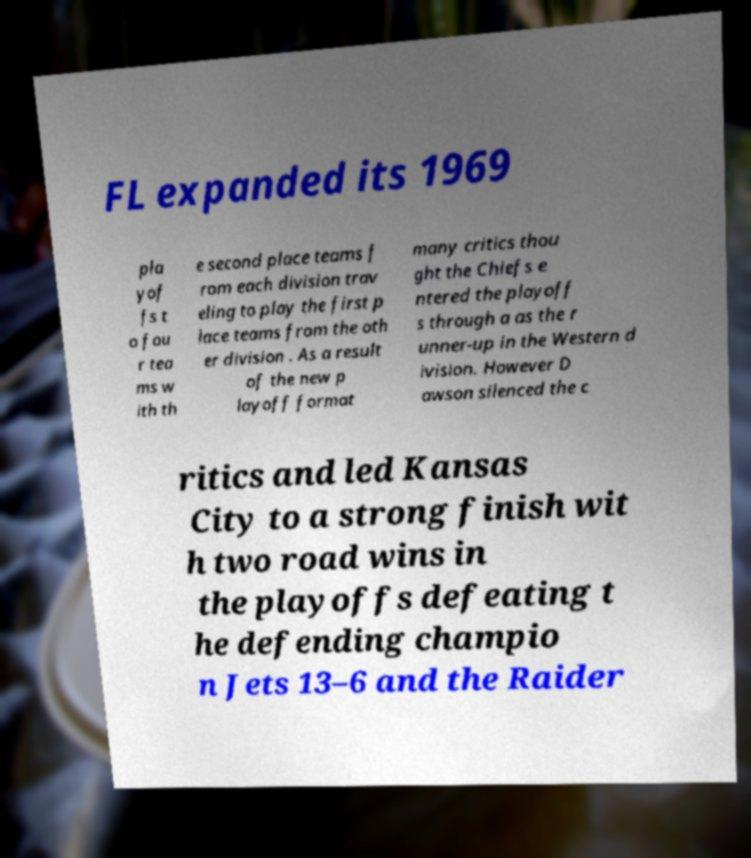For documentation purposes, I need the text within this image transcribed. Could you provide that? FL expanded its 1969 pla yof fs t o fou r tea ms w ith th e second place teams f rom each division trav eling to play the first p lace teams from the oth er division . As a result of the new p layoff format many critics thou ght the Chiefs e ntered the playoff s through a as the r unner-up in the Western d ivision. However D awson silenced the c ritics and led Kansas City to a strong finish wit h two road wins in the playoffs defeating t he defending champio n Jets 13–6 and the Raider 